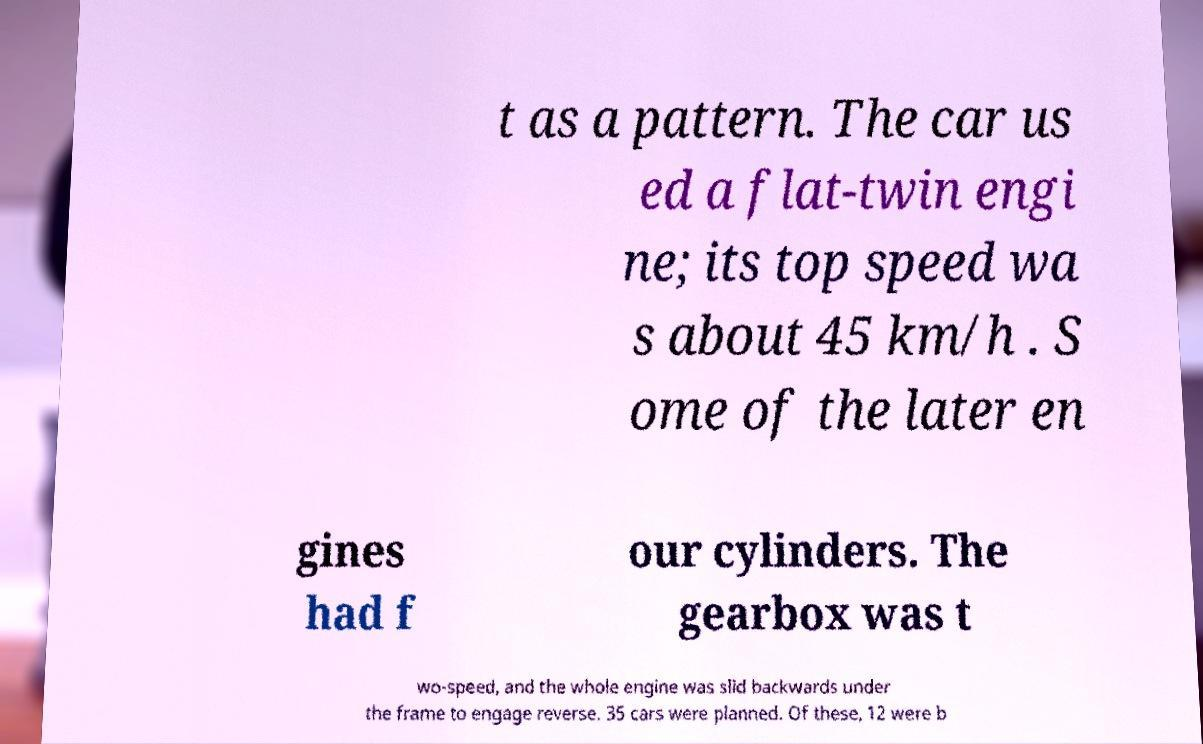For documentation purposes, I need the text within this image transcribed. Could you provide that? t as a pattern. The car us ed a flat-twin engi ne; its top speed wa s about 45 km/h . S ome of the later en gines had f our cylinders. The gearbox was t wo-speed, and the whole engine was slid backwards under the frame to engage reverse. 35 cars were planned. Of these, 12 were b 